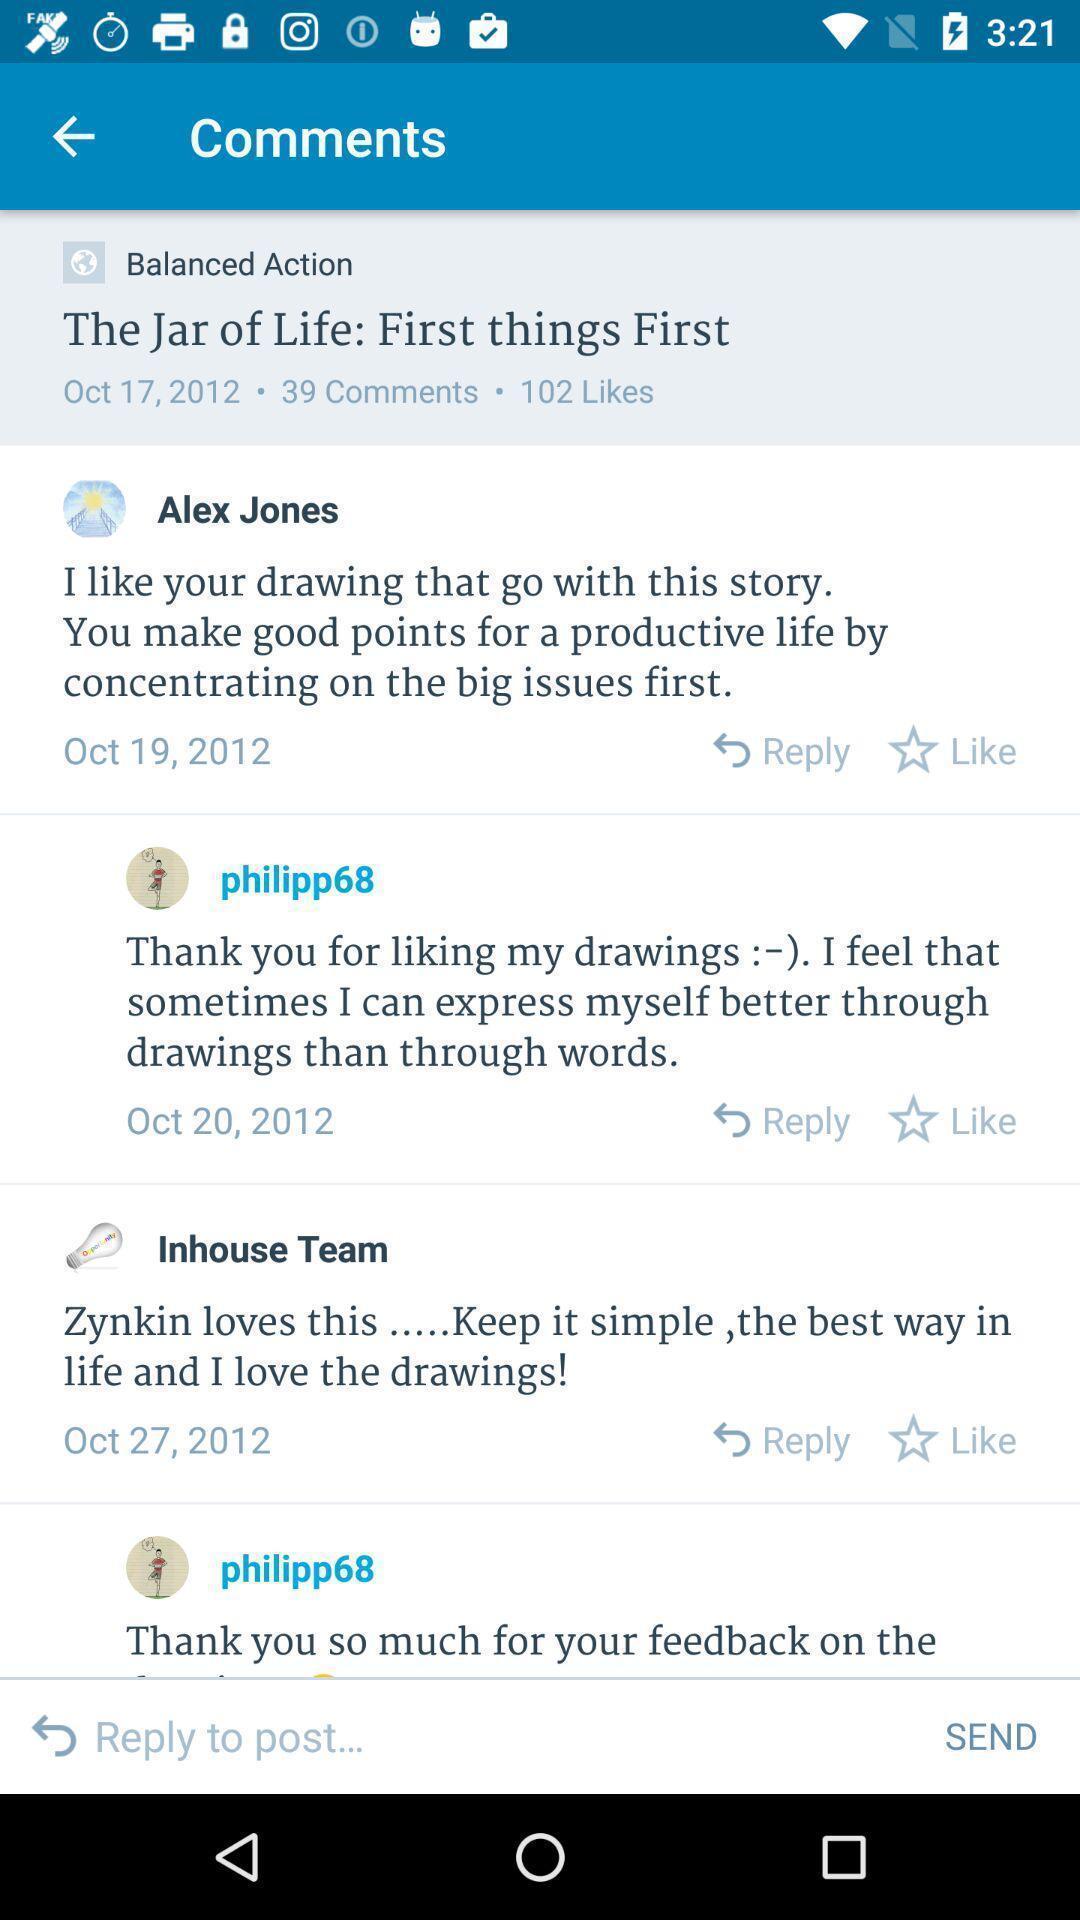Explain what's happening in this screen capture. Screen displaying the comments page. 